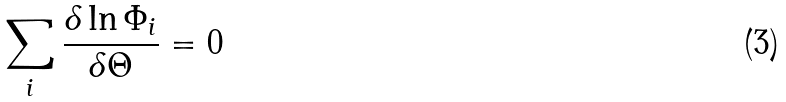<formula> <loc_0><loc_0><loc_500><loc_500>\sum _ { i } \frac { \delta \ln \Phi _ { i } } { \delta \Theta } = 0</formula> 